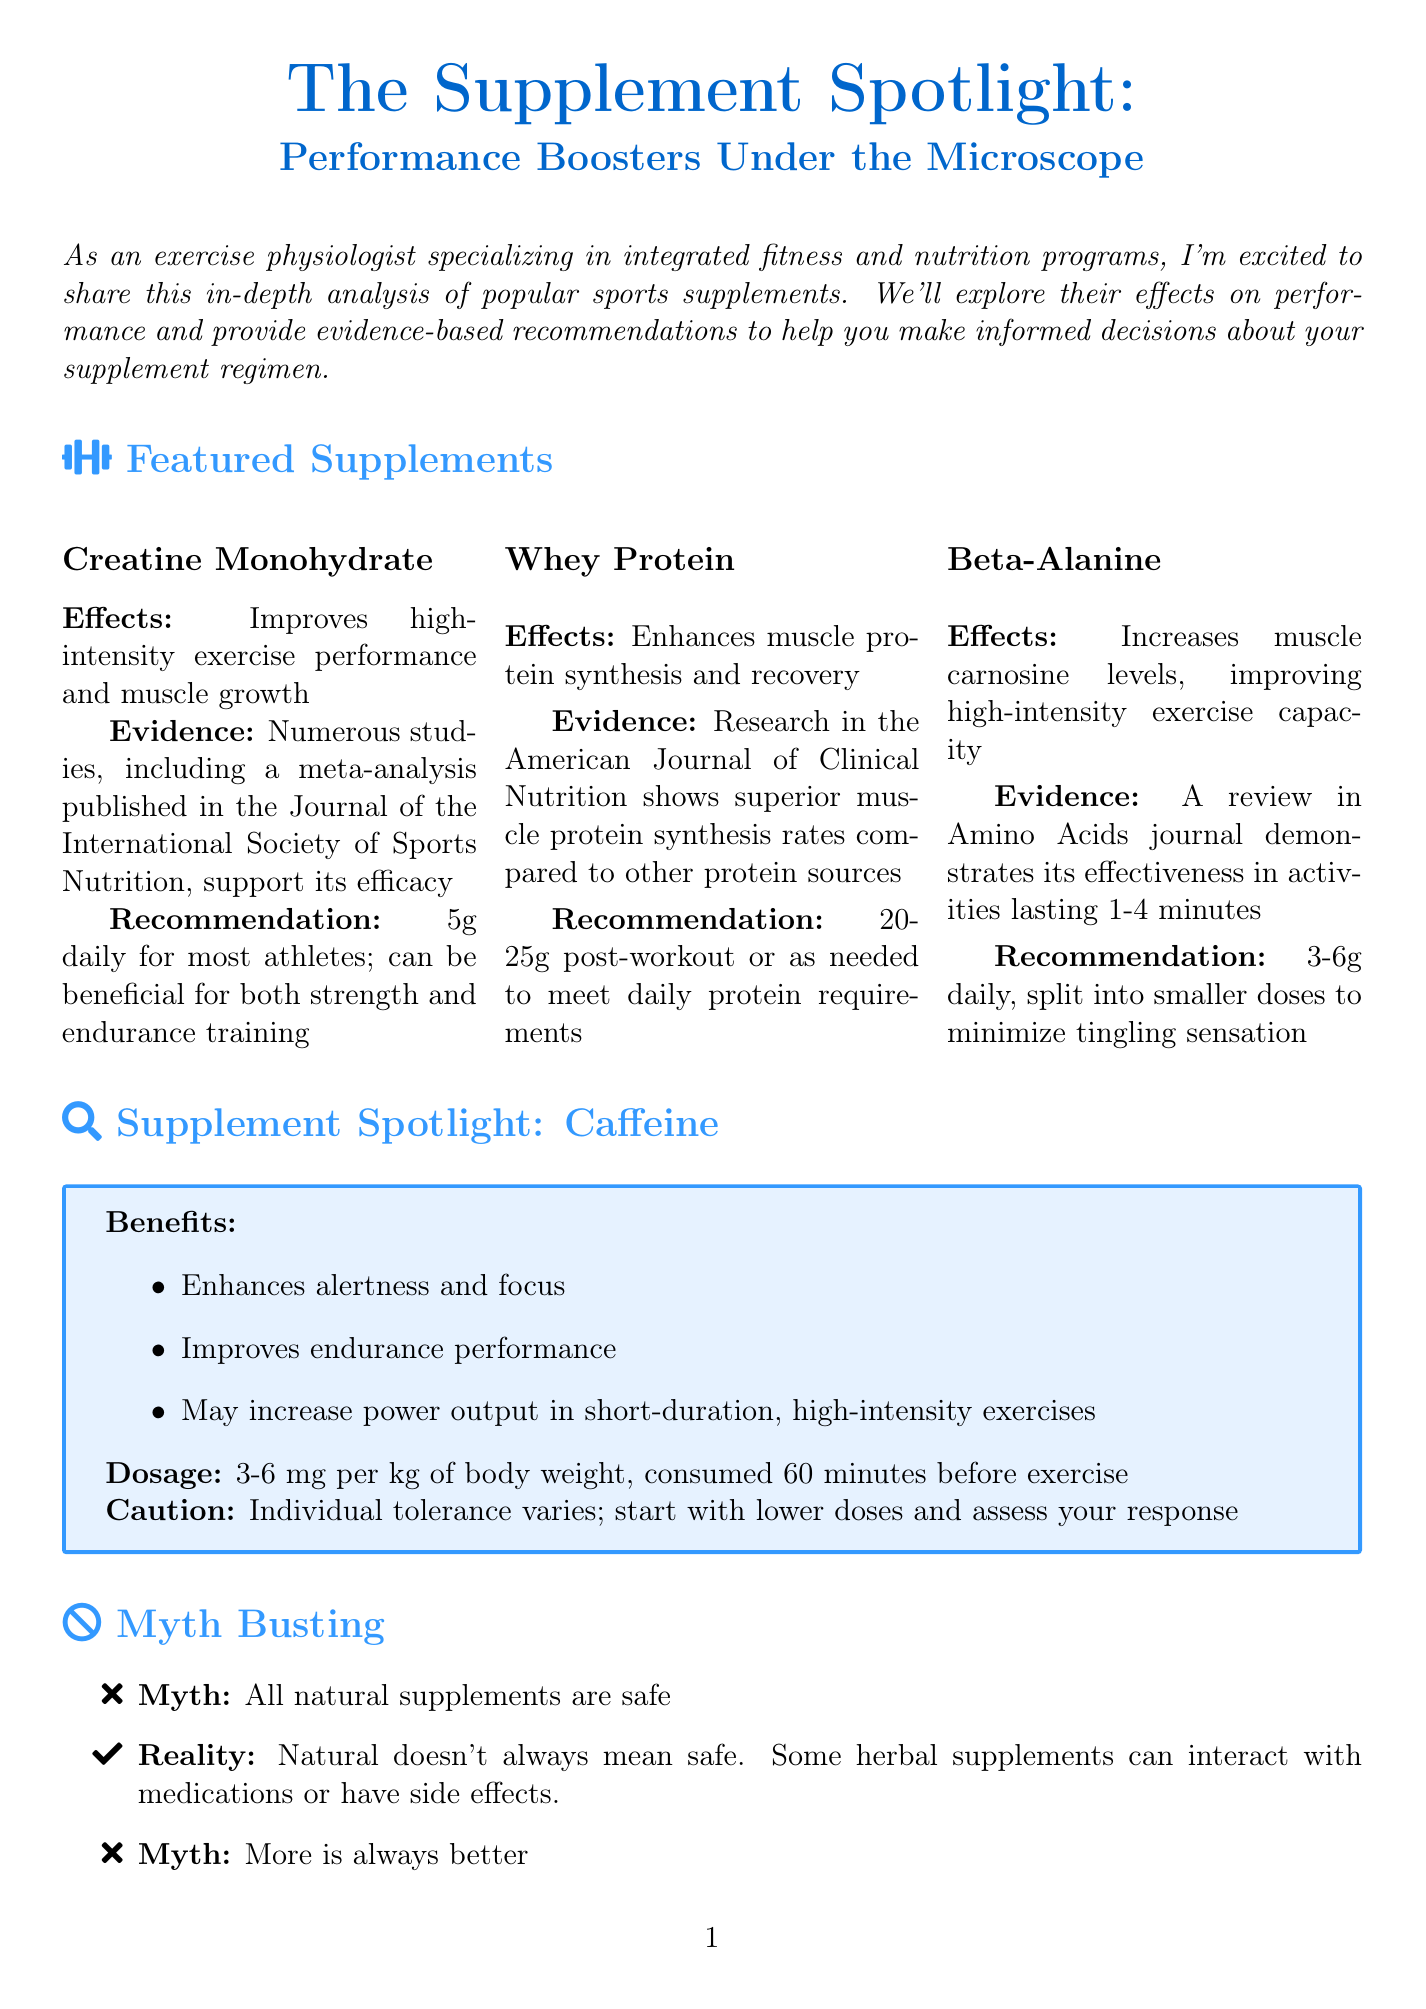What is the newsletter title? The title is explicitly stated in the header of the document.
Answer: The Supplement Spotlight: Performance Boosters Under the Microscope What is the recommended dosage of creatine monohydrate? The dosage is specified in the section detailing this supplement.
Answer: 5g daily Which supplement enhances muscle protein synthesis? This information is found in the featured supplements section.
Answer: Whey Protein What is a caution associated with caffeine supplementation? Cautionary information is provided within the caffeine spotlight section.
Answer: Individual tolerance varies What are two topics of upcoming research mentioned? These are listed in the section describing emerging research.
Answer: Nitrate supplementation for endurance performance, collagen peptides for joint health in athletes What is the reality behind the myth that all natural supplements are safe? This myth and reality are outlined in the myth-busting section of the document.
Answer: Natural doesn't always mean safe What is the recommended amount of beta-alanine? The recommendation is clearly defined in the beta-alanine section of featured supplements.
Answer: 3-6g daily What should athletes focus on before using supplements, according to the personalized advice? This guidance can be found in the personalized advice section of the document.
Answer: A balanced diet What type of document is this? The formatting and content indicate the nature of the document.
Answer: Newsletter 